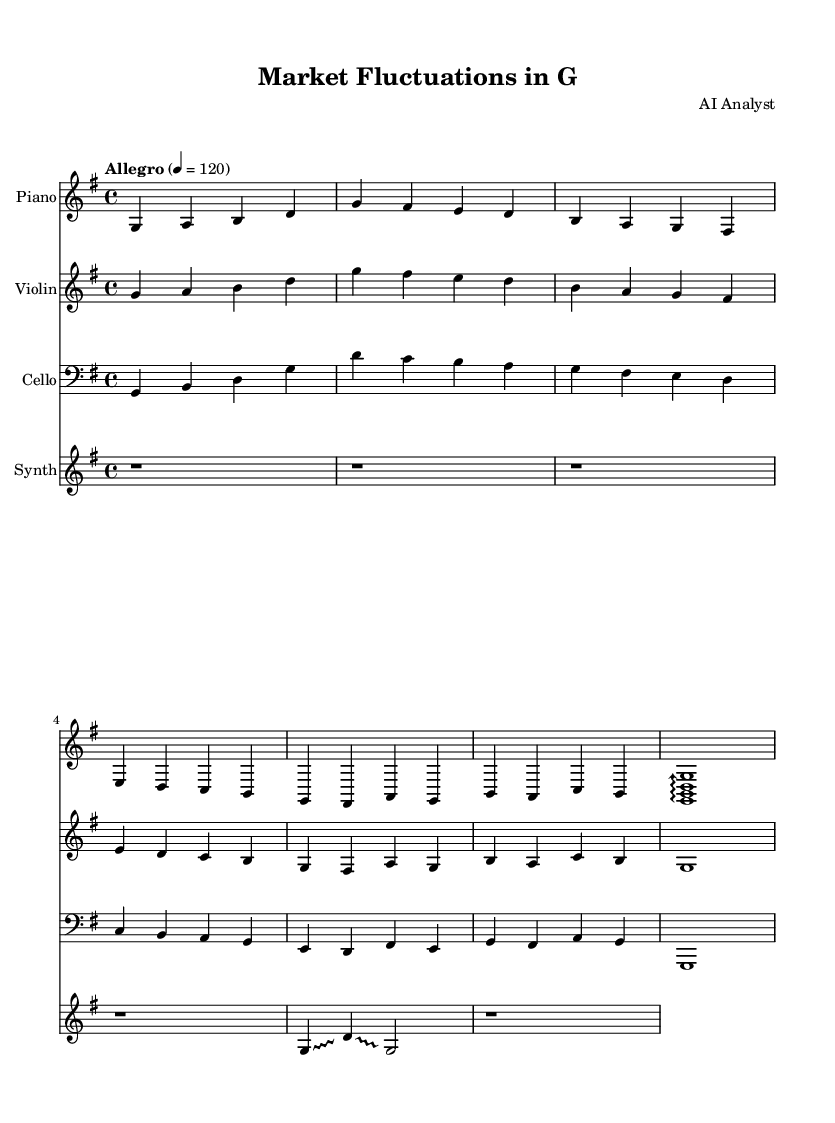What is the key signature of this music? The key signature is G major, indicated by one sharp (F#) on the staff.
Answer: G major What is the time signature of this music? The time signature is 4/4, which means there are four beats in a measure and the quarter note gets one beat.
Answer: 4/4 What is the tempo marking of this music? The tempo marking is "Allegro," which indicates a fast, lively tempo, often around 120 beats per minute.
Answer: Allegro How many instruments are used in this composition? There are four instruments used: piano, violin, cello, and synthesizer, as indicated by the separate staves in the score.
Answer: Four Which instrument plays the longest note value in this piece? The synthesizer plays whole notes, indicated by the 'g1' at the end, which lasts for an entire measure.
Answer: Synthesizer What type of musical technique is used by the synthesizer? The synthesizer uses a glissando technique, which is shown by the notation that indicates sliding between notes.
Answer: Glissando What is the final note value played by the cello? The final note played by the cello is a whole note, as shown in the final measure with 'g1'.
Answer: Whole note 